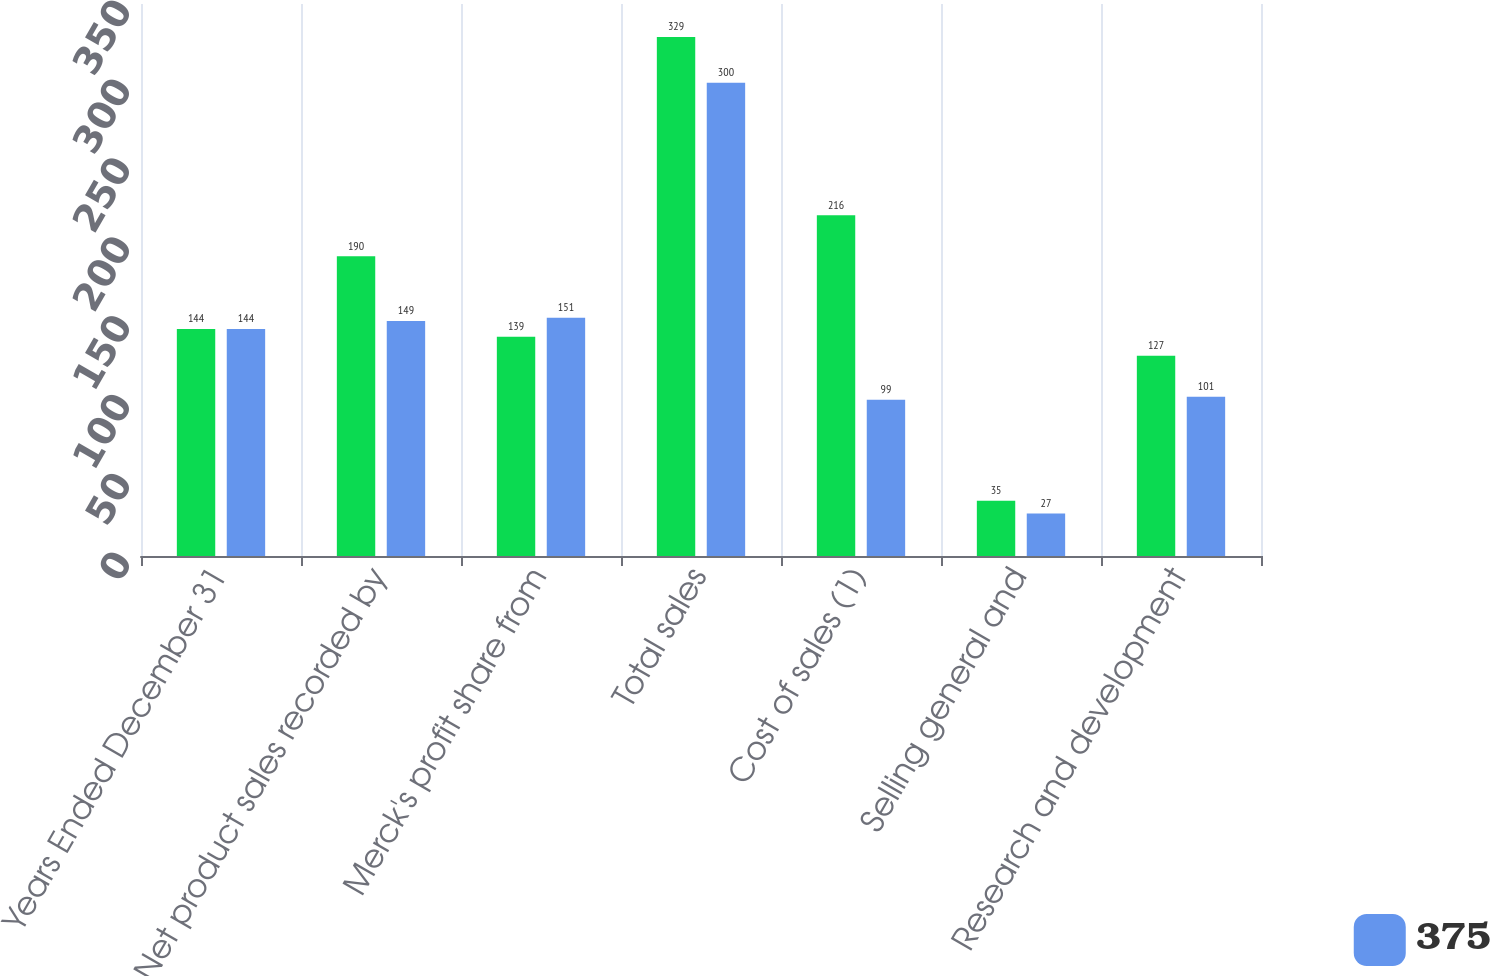<chart> <loc_0><loc_0><loc_500><loc_500><stacked_bar_chart><ecel><fcel>Years Ended December 31<fcel>Net product sales recorded by<fcel>Merck's profit share from<fcel>Total sales<fcel>Cost of sales (1)<fcel>Selling general and<fcel>Research and development<nl><fcel>nan<fcel>144<fcel>190<fcel>139<fcel>329<fcel>216<fcel>35<fcel>127<nl><fcel>375<fcel>144<fcel>149<fcel>151<fcel>300<fcel>99<fcel>27<fcel>101<nl></chart> 